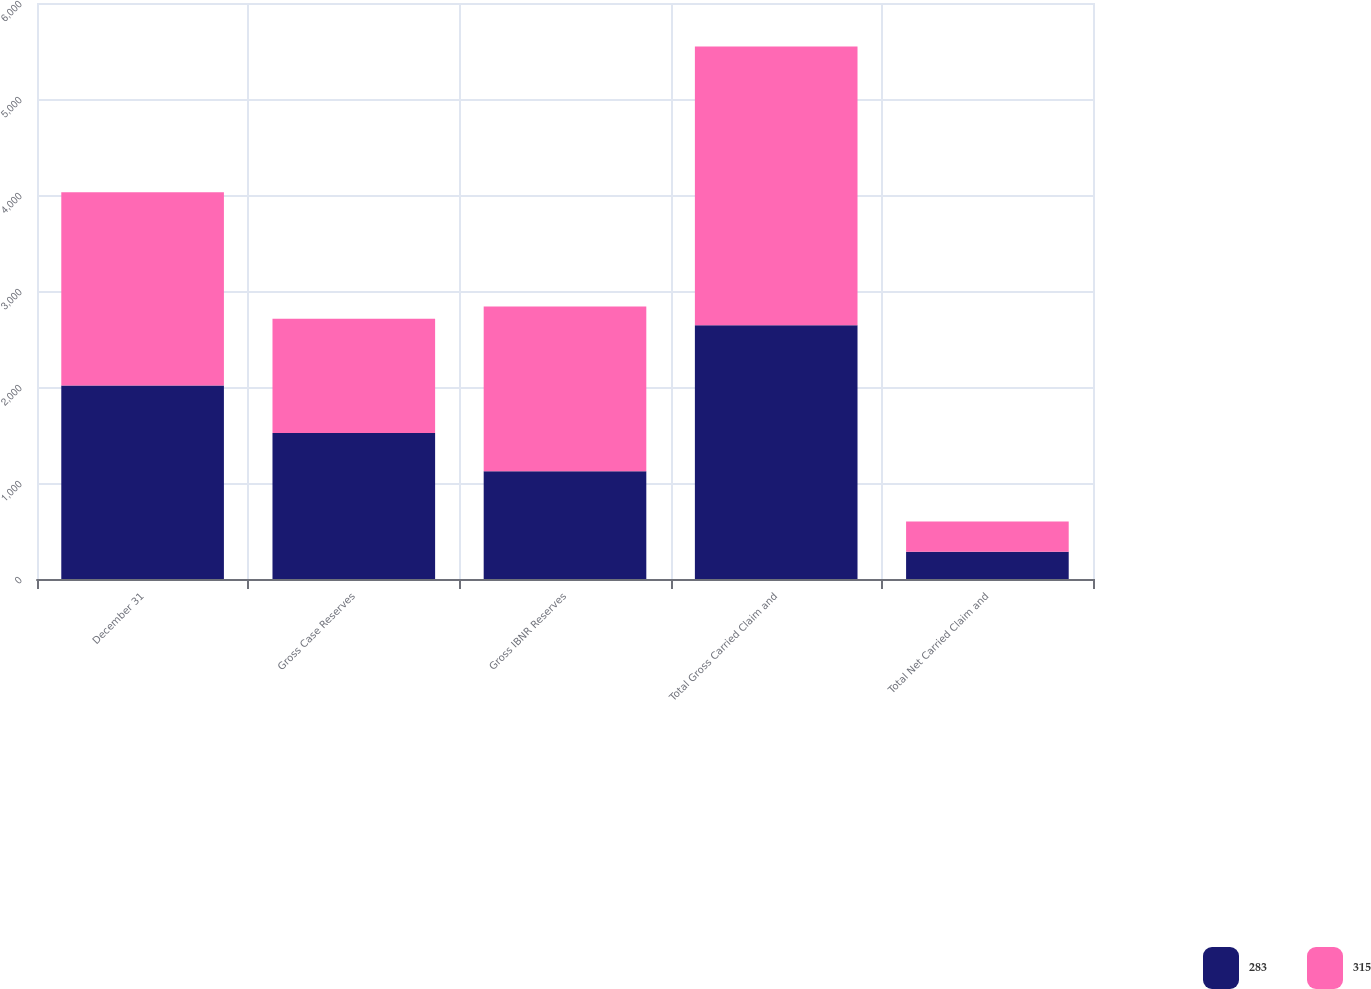Convert chart to OTSL. <chart><loc_0><loc_0><loc_500><loc_500><stacked_bar_chart><ecel><fcel>December 31<fcel>Gross Case Reserves<fcel>Gross IBNR Reserves<fcel>Total Gross Carried Claim and<fcel>Total Net Carried Claim and<nl><fcel>283<fcel>2015<fcel>1521<fcel>1123<fcel>2644<fcel>283<nl><fcel>315<fcel>2014<fcel>1189<fcel>1715<fcel>2904<fcel>315<nl></chart> 